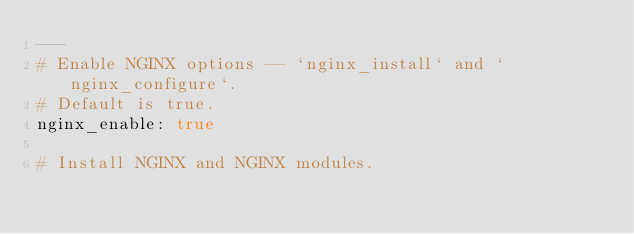<code> <loc_0><loc_0><loc_500><loc_500><_YAML_>---
# Enable NGINX options -- `nginx_install` and `nginx_configure`.
# Default is true.
nginx_enable: true

# Install NGINX and NGINX modules.</code> 